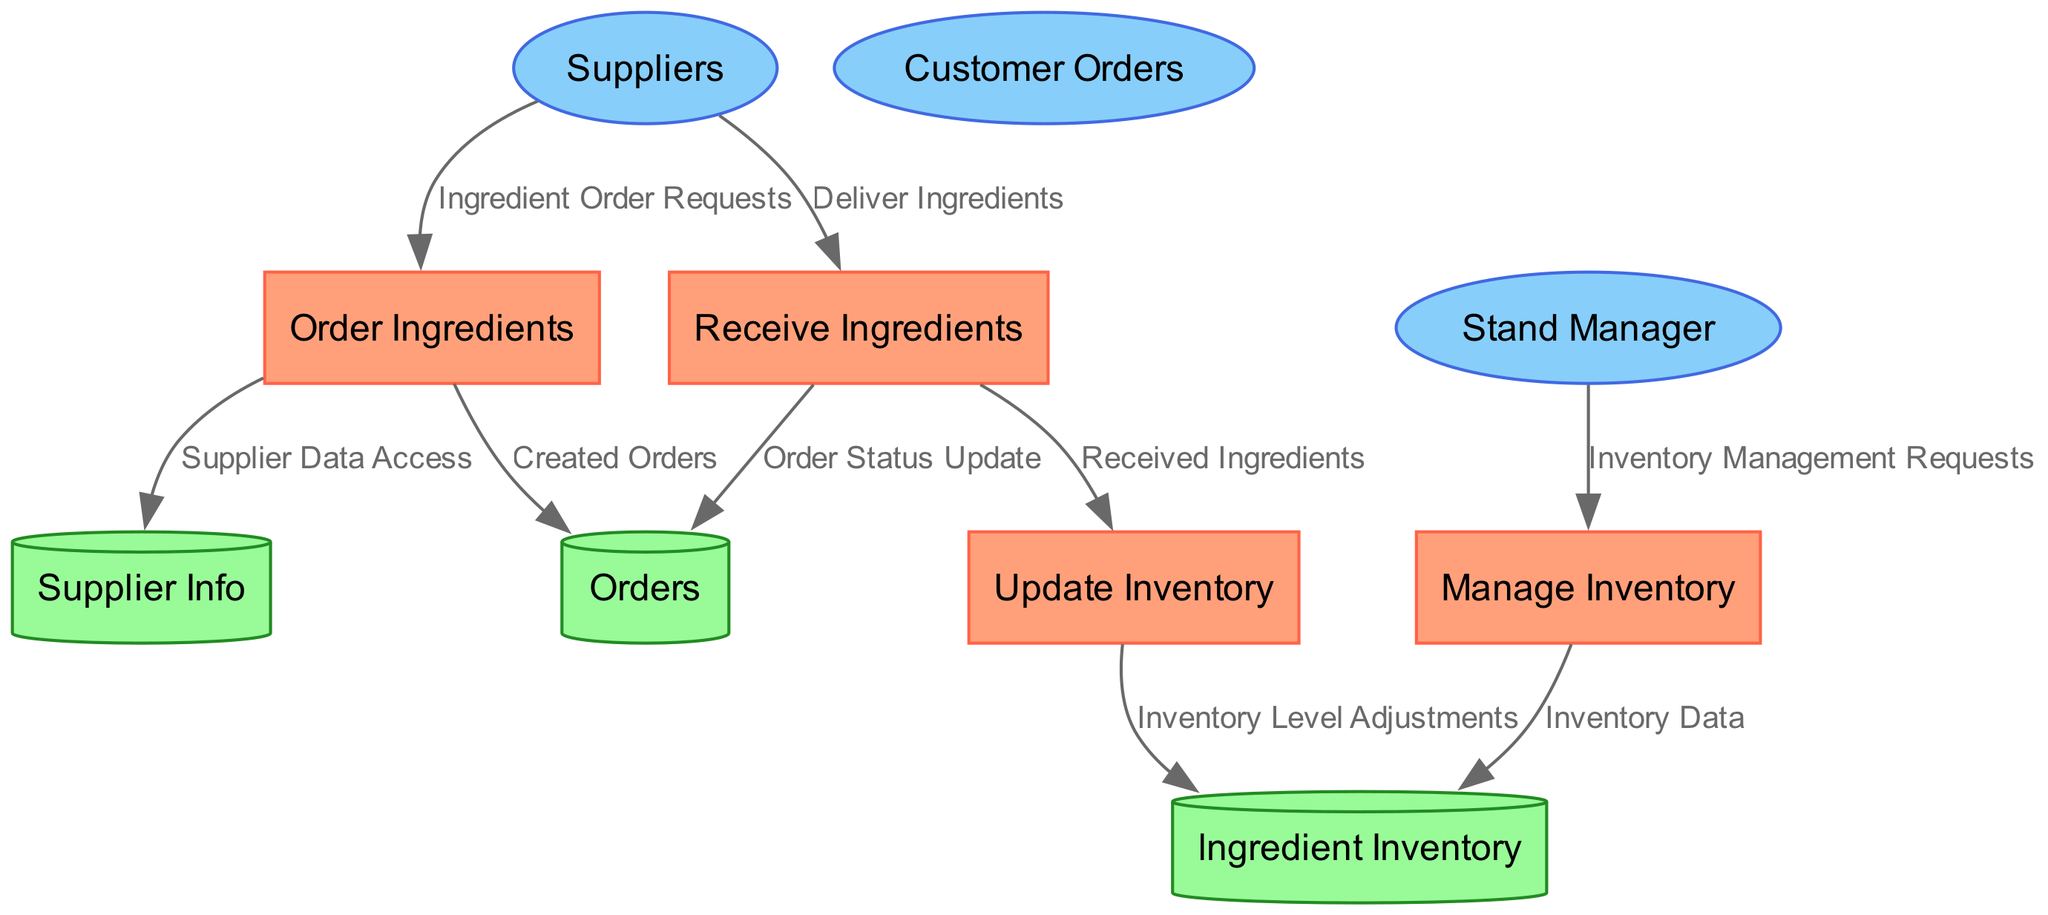What is the name of the process that manages ingredient ordering? The process responsible for ordering ingredients is identified as "Order Ingredients" in the diagram.
Answer: Order Ingredients How many data stores are present in the diagram? By counting the nodes designated as data stores, there are three, specifically labeled as Ingredient Inventory, Supplier Info, and Orders.
Answer: 3 What type of external entity is "Stand Manager"? In the diagram, the "Stand Manager" is categorized as an external entity, specifically related to overseeing operations and inventory management.
Answer: External Entity What is the source of the data flow labeled "Deliver Ingredients"? The source of the "Deliver Ingredients" data flow is identified as "Suppliers" in the diagram, indicating where the ingredient deliveries originate from.
Answer: Suppliers Which process updates inventory levels? The process that updates inventory levels is called "Update Inventory," which is explicitly described in the diagram.
Answer: Update Inventory What is logged when ingredients are received from suppliers? When ingredients are received, an "Order Status Update" is logged, which is reflected in the data flows connecting the processes and data stores.
Answer: Order Status Update Which data store contains current stock levels of ingredients? The data store that contains current stock levels of ingredients is labeled as "Ingredient Inventory," directly indicating its purpose in the system.
Answer: Ingredient Inventory What does the "Inventory Data" data flow represent? The "Inventory Data" data flow represents the current inventory levels and updates being sent from the Manage Inventory process to the Ingredient Inventory data store.
Answer: Current inventory levels and updates What is the destination of the data flow "Created Orders"? The destination of the "Created Orders" data flow is the "Orders" data store, which documents all the placed orders in the inventory management system.
Answer: Orders 